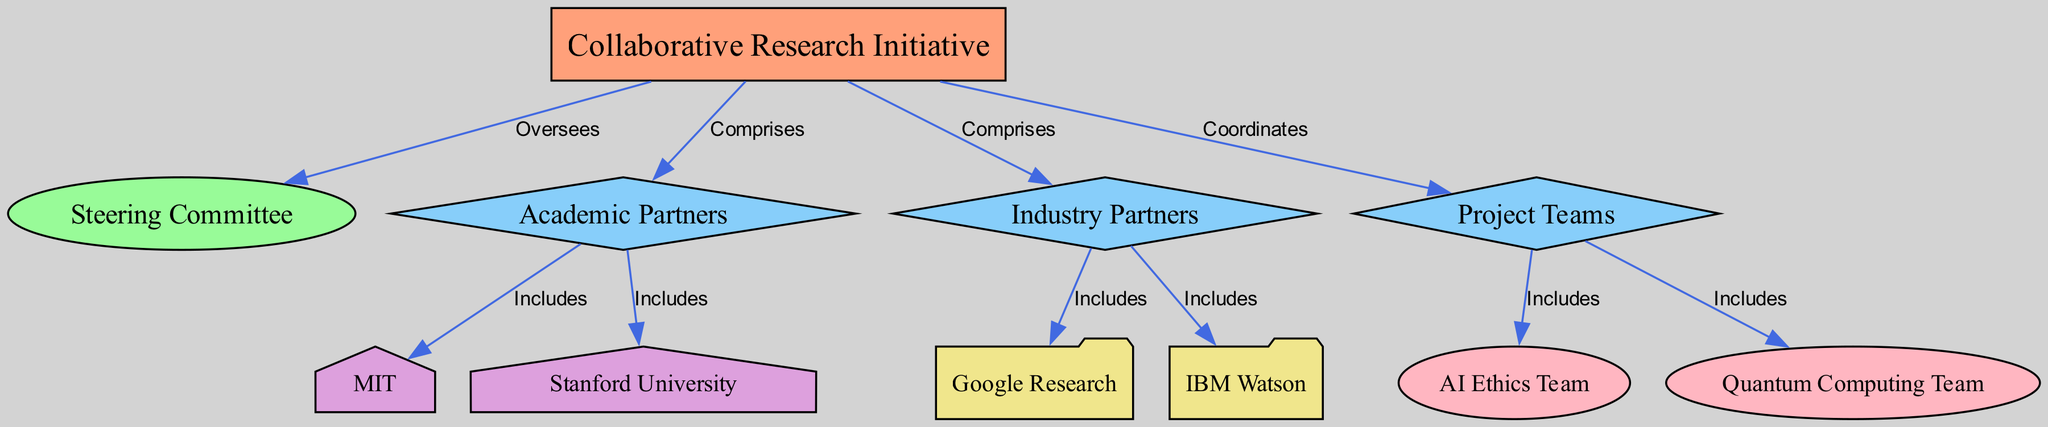What is the top node in the organizational chart? The top node in the organizational chart is the "Collaborative Research Initiative," which serves as the root of the hierarchy.
Answer: Collaborative Research Initiative How many branches are there in the chart? The chart has three branches: "Academic Partners," "Industry Partners," and "Project Teams." These branches come off the root node.
Answer: 3 Which university is included as an academic partner? The diagram includes "MIT" as one of the academic partners listed under the "Academic Partners" branch.
Answer: MIT What is the role of the Steering Committee? The Steering Committee is responsible for overseeing the entire collaborative initiative, as indicated by its connection to the root node with the label "Oversees."
Answer: Oversees How many teams are part of the Project Teams branch? The Project Teams branch contains two teams: the "AI Ethics Team" and the "Quantum Computing Team," both of which are connected to this branch.
Answer: 2 Which nodes are classified as companies in the chart? The companies listed in the diagram are "Google Research" and "IBM Watson," found under the "Industry Partners" branch.
Answer: Google Research and IBM Watson Which node directly oversees the Project Teams? The node that directly oversees the Project Teams is the "Collaborative Research Initiative," which coordinates the teams according to the edge label.
Answer: Collaborative Research Initiative What type of entity is "Stanford University"? "Stanford University" is classified as a university, distinguished by its shape and color in the diagram representing academic institutions.
Answer: university How are the Project Teams connected to the Collaborative Research Initiative? The Project Teams are connected to the Collaborative Research Initiative through the edge labeled "Coordinates," indicating an overseeing relationship.
Answer: Coordinates Which type of node represents academic partners? Academic partners in the diagram are represented by branch nodes, specifically categorized as "Academic Partners" and further detailing the universities included.
Answer: branch 